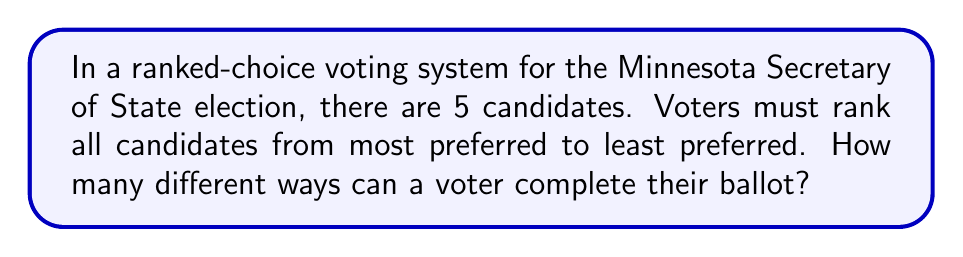Could you help me with this problem? Let's approach this step-by-step:

1) In a ranked-choice voting system where all candidates must be ranked, we are essentially dealing with a permutation of all candidates.

2) The number of ways to arrange n distinct objects is given by the factorial of n, denoted as n!.

3) In this case, we have 5 candidates, so n = 5.

4) Therefore, the number of ways to rank 5 candidates is 5!.

5) Let's calculate 5!:
   
   $$5! = 5 \times 4 \times 3 \times 2 \times 1 = 120$$

6) This means there are 120 different ways a voter can rank the 5 candidates on their ballot.

7) Each of these 120 permutations represents a unique way of expressing voter preferences, which is crucial for a campaign manager to understand when developing strategies to maximize their candidate's chances of winning in a ranked-choice voting system.
Answer: 120 